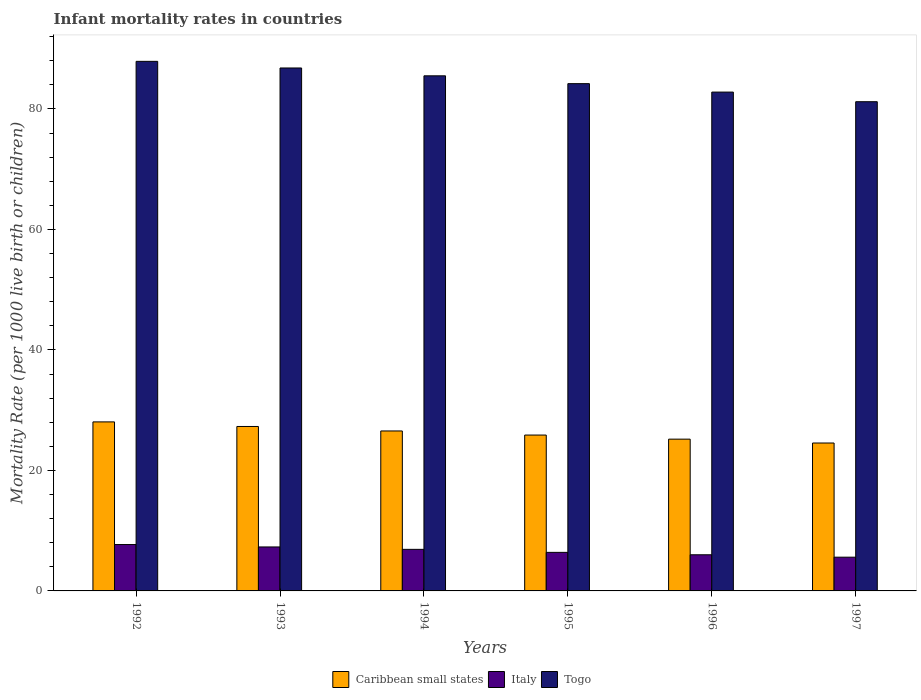How many different coloured bars are there?
Your answer should be compact. 3. Are the number of bars per tick equal to the number of legend labels?
Your response must be concise. Yes. How many bars are there on the 1st tick from the left?
Give a very brief answer. 3. How many bars are there on the 5th tick from the right?
Give a very brief answer. 3. What is the label of the 6th group of bars from the left?
Provide a short and direct response. 1997. What is the infant mortality rate in Caribbean small states in 1995?
Your answer should be compact. 25.87. Across all years, what is the maximum infant mortality rate in Togo?
Provide a succinct answer. 87.9. Across all years, what is the minimum infant mortality rate in Caribbean small states?
Provide a short and direct response. 24.55. What is the total infant mortality rate in Caribbean small states in the graph?
Your answer should be very brief. 157.52. What is the difference between the infant mortality rate in Italy in 1993 and that in 1995?
Ensure brevity in your answer.  0.9. What is the difference between the infant mortality rate in Caribbean small states in 1992 and the infant mortality rate in Togo in 1996?
Offer a very short reply. -54.74. What is the average infant mortality rate in Caribbean small states per year?
Provide a short and direct response. 26.25. In the year 1993, what is the difference between the infant mortality rate in Caribbean small states and infant mortality rate in Italy?
Your answer should be compact. 20. What is the ratio of the infant mortality rate in Caribbean small states in 1992 to that in 1995?
Provide a succinct answer. 1.08. Is the difference between the infant mortality rate in Caribbean small states in 1993 and 1994 greater than the difference between the infant mortality rate in Italy in 1993 and 1994?
Give a very brief answer. Yes. What is the difference between the highest and the second highest infant mortality rate in Italy?
Your response must be concise. 0.4. What is the difference between the highest and the lowest infant mortality rate in Caribbean small states?
Your answer should be very brief. 3.5. In how many years, is the infant mortality rate in Togo greater than the average infant mortality rate in Togo taken over all years?
Provide a short and direct response. 3. What does the 1st bar from the left in 1996 represents?
Offer a terse response. Caribbean small states. What does the 2nd bar from the right in 1994 represents?
Your answer should be very brief. Italy. Is it the case that in every year, the sum of the infant mortality rate in Togo and infant mortality rate in Italy is greater than the infant mortality rate in Caribbean small states?
Provide a succinct answer. Yes. How many years are there in the graph?
Offer a very short reply. 6. What is the difference between two consecutive major ticks on the Y-axis?
Your response must be concise. 20. Are the values on the major ticks of Y-axis written in scientific E-notation?
Offer a very short reply. No. Does the graph contain grids?
Ensure brevity in your answer.  No. How many legend labels are there?
Your answer should be compact. 3. How are the legend labels stacked?
Provide a short and direct response. Horizontal. What is the title of the graph?
Offer a terse response. Infant mortality rates in countries. What is the label or title of the Y-axis?
Keep it short and to the point. Mortality Rate (per 1000 live birth or children). What is the Mortality Rate (per 1000 live birth or children) in Caribbean small states in 1992?
Provide a succinct answer. 28.06. What is the Mortality Rate (per 1000 live birth or children) in Italy in 1992?
Your answer should be compact. 7.7. What is the Mortality Rate (per 1000 live birth or children) in Togo in 1992?
Offer a terse response. 87.9. What is the Mortality Rate (per 1000 live birth or children) of Caribbean small states in 1993?
Ensure brevity in your answer.  27.3. What is the Mortality Rate (per 1000 live birth or children) of Italy in 1993?
Offer a terse response. 7.3. What is the Mortality Rate (per 1000 live birth or children) of Togo in 1993?
Your response must be concise. 86.8. What is the Mortality Rate (per 1000 live birth or children) of Caribbean small states in 1994?
Your answer should be compact. 26.55. What is the Mortality Rate (per 1000 live birth or children) in Togo in 1994?
Offer a terse response. 85.5. What is the Mortality Rate (per 1000 live birth or children) in Caribbean small states in 1995?
Your response must be concise. 25.87. What is the Mortality Rate (per 1000 live birth or children) of Togo in 1995?
Ensure brevity in your answer.  84.2. What is the Mortality Rate (per 1000 live birth or children) in Caribbean small states in 1996?
Your answer should be very brief. 25.19. What is the Mortality Rate (per 1000 live birth or children) of Italy in 1996?
Keep it short and to the point. 6. What is the Mortality Rate (per 1000 live birth or children) of Togo in 1996?
Offer a terse response. 82.8. What is the Mortality Rate (per 1000 live birth or children) of Caribbean small states in 1997?
Keep it short and to the point. 24.55. What is the Mortality Rate (per 1000 live birth or children) in Italy in 1997?
Your response must be concise. 5.6. What is the Mortality Rate (per 1000 live birth or children) of Togo in 1997?
Make the answer very short. 81.2. Across all years, what is the maximum Mortality Rate (per 1000 live birth or children) of Caribbean small states?
Offer a very short reply. 28.06. Across all years, what is the maximum Mortality Rate (per 1000 live birth or children) in Togo?
Your response must be concise. 87.9. Across all years, what is the minimum Mortality Rate (per 1000 live birth or children) in Caribbean small states?
Provide a short and direct response. 24.55. Across all years, what is the minimum Mortality Rate (per 1000 live birth or children) in Italy?
Make the answer very short. 5.6. Across all years, what is the minimum Mortality Rate (per 1000 live birth or children) in Togo?
Give a very brief answer. 81.2. What is the total Mortality Rate (per 1000 live birth or children) in Caribbean small states in the graph?
Ensure brevity in your answer.  157.52. What is the total Mortality Rate (per 1000 live birth or children) in Italy in the graph?
Your response must be concise. 39.9. What is the total Mortality Rate (per 1000 live birth or children) of Togo in the graph?
Ensure brevity in your answer.  508.4. What is the difference between the Mortality Rate (per 1000 live birth or children) in Caribbean small states in 1992 and that in 1993?
Ensure brevity in your answer.  0.76. What is the difference between the Mortality Rate (per 1000 live birth or children) of Caribbean small states in 1992 and that in 1994?
Provide a short and direct response. 1.5. What is the difference between the Mortality Rate (per 1000 live birth or children) of Caribbean small states in 1992 and that in 1995?
Your answer should be very brief. 2.18. What is the difference between the Mortality Rate (per 1000 live birth or children) in Caribbean small states in 1992 and that in 1996?
Your response must be concise. 2.86. What is the difference between the Mortality Rate (per 1000 live birth or children) in Italy in 1992 and that in 1996?
Ensure brevity in your answer.  1.7. What is the difference between the Mortality Rate (per 1000 live birth or children) of Togo in 1992 and that in 1996?
Offer a very short reply. 5.1. What is the difference between the Mortality Rate (per 1000 live birth or children) in Caribbean small states in 1992 and that in 1997?
Give a very brief answer. 3.5. What is the difference between the Mortality Rate (per 1000 live birth or children) in Togo in 1992 and that in 1997?
Provide a succinct answer. 6.7. What is the difference between the Mortality Rate (per 1000 live birth or children) of Caribbean small states in 1993 and that in 1994?
Offer a very short reply. 0.74. What is the difference between the Mortality Rate (per 1000 live birth or children) of Italy in 1993 and that in 1994?
Ensure brevity in your answer.  0.4. What is the difference between the Mortality Rate (per 1000 live birth or children) of Togo in 1993 and that in 1994?
Give a very brief answer. 1.3. What is the difference between the Mortality Rate (per 1000 live birth or children) of Caribbean small states in 1993 and that in 1995?
Give a very brief answer. 1.42. What is the difference between the Mortality Rate (per 1000 live birth or children) in Caribbean small states in 1993 and that in 1996?
Ensure brevity in your answer.  2.1. What is the difference between the Mortality Rate (per 1000 live birth or children) of Togo in 1993 and that in 1996?
Ensure brevity in your answer.  4. What is the difference between the Mortality Rate (per 1000 live birth or children) of Caribbean small states in 1993 and that in 1997?
Your answer should be very brief. 2.74. What is the difference between the Mortality Rate (per 1000 live birth or children) of Italy in 1993 and that in 1997?
Offer a very short reply. 1.7. What is the difference between the Mortality Rate (per 1000 live birth or children) of Togo in 1993 and that in 1997?
Make the answer very short. 5.6. What is the difference between the Mortality Rate (per 1000 live birth or children) of Caribbean small states in 1994 and that in 1995?
Offer a terse response. 0.68. What is the difference between the Mortality Rate (per 1000 live birth or children) in Italy in 1994 and that in 1995?
Provide a short and direct response. 0.5. What is the difference between the Mortality Rate (per 1000 live birth or children) in Togo in 1994 and that in 1995?
Your response must be concise. 1.3. What is the difference between the Mortality Rate (per 1000 live birth or children) in Caribbean small states in 1994 and that in 1996?
Give a very brief answer. 1.36. What is the difference between the Mortality Rate (per 1000 live birth or children) of Togo in 1994 and that in 1996?
Keep it short and to the point. 2.7. What is the difference between the Mortality Rate (per 1000 live birth or children) of Caribbean small states in 1994 and that in 1997?
Offer a very short reply. 2. What is the difference between the Mortality Rate (per 1000 live birth or children) in Togo in 1994 and that in 1997?
Offer a terse response. 4.3. What is the difference between the Mortality Rate (per 1000 live birth or children) of Caribbean small states in 1995 and that in 1996?
Provide a succinct answer. 0.68. What is the difference between the Mortality Rate (per 1000 live birth or children) in Italy in 1995 and that in 1996?
Your answer should be compact. 0.4. What is the difference between the Mortality Rate (per 1000 live birth or children) of Caribbean small states in 1995 and that in 1997?
Give a very brief answer. 1.32. What is the difference between the Mortality Rate (per 1000 live birth or children) of Caribbean small states in 1996 and that in 1997?
Provide a short and direct response. 0.64. What is the difference between the Mortality Rate (per 1000 live birth or children) in Italy in 1996 and that in 1997?
Make the answer very short. 0.4. What is the difference between the Mortality Rate (per 1000 live birth or children) of Caribbean small states in 1992 and the Mortality Rate (per 1000 live birth or children) of Italy in 1993?
Your response must be concise. 20.76. What is the difference between the Mortality Rate (per 1000 live birth or children) of Caribbean small states in 1992 and the Mortality Rate (per 1000 live birth or children) of Togo in 1993?
Ensure brevity in your answer.  -58.74. What is the difference between the Mortality Rate (per 1000 live birth or children) in Italy in 1992 and the Mortality Rate (per 1000 live birth or children) in Togo in 1993?
Your answer should be compact. -79.1. What is the difference between the Mortality Rate (per 1000 live birth or children) in Caribbean small states in 1992 and the Mortality Rate (per 1000 live birth or children) in Italy in 1994?
Offer a very short reply. 21.16. What is the difference between the Mortality Rate (per 1000 live birth or children) in Caribbean small states in 1992 and the Mortality Rate (per 1000 live birth or children) in Togo in 1994?
Make the answer very short. -57.44. What is the difference between the Mortality Rate (per 1000 live birth or children) of Italy in 1992 and the Mortality Rate (per 1000 live birth or children) of Togo in 1994?
Keep it short and to the point. -77.8. What is the difference between the Mortality Rate (per 1000 live birth or children) in Caribbean small states in 1992 and the Mortality Rate (per 1000 live birth or children) in Italy in 1995?
Provide a short and direct response. 21.66. What is the difference between the Mortality Rate (per 1000 live birth or children) in Caribbean small states in 1992 and the Mortality Rate (per 1000 live birth or children) in Togo in 1995?
Your response must be concise. -56.14. What is the difference between the Mortality Rate (per 1000 live birth or children) in Italy in 1992 and the Mortality Rate (per 1000 live birth or children) in Togo in 1995?
Give a very brief answer. -76.5. What is the difference between the Mortality Rate (per 1000 live birth or children) of Caribbean small states in 1992 and the Mortality Rate (per 1000 live birth or children) of Italy in 1996?
Make the answer very short. 22.06. What is the difference between the Mortality Rate (per 1000 live birth or children) of Caribbean small states in 1992 and the Mortality Rate (per 1000 live birth or children) of Togo in 1996?
Provide a short and direct response. -54.74. What is the difference between the Mortality Rate (per 1000 live birth or children) in Italy in 1992 and the Mortality Rate (per 1000 live birth or children) in Togo in 1996?
Offer a terse response. -75.1. What is the difference between the Mortality Rate (per 1000 live birth or children) in Caribbean small states in 1992 and the Mortality Rate (per 1000 live birth or children) in Italy in 1997?
Offer a terse response. 22.46. What is the difference between the Mortality Rate (per 1000 live birth or children) in Caribbean small states in 1992 and the Mortality Rate (per 1000 live birth or children) in Togo in 1997?
Your answer should be compact. -53.14. What is the difference between the Mortality Rate (per 1000 live birth or children) in Italy in 1992 and the Mortality Rate (per 1000 live birth or children) in Togo in 1997?
Your answer should be very brief. -73.5. What is the difference between the Mortality Rate (per 1000 live birth or children) of Caribbean small states in 1993 and the Mortality Rate (per 1000 live birth or children) of Italy in 1994?
Make the answer very short. 20.4. What is the difference between the Mortality Rate (per 1000 live birth or children) in Caribbean small states in 1993 and the Mortality Rate (per 1000 live birth or children) in Togo in 1994?
Your answer should be compact. -58.2. What is the difference between the Mortality Rate (per 1000 live birth or children) in Italy in 1993 and the Mortality Rate (per 1000 live birth or children) in Togo in 1994?
Give a very brief answer. -78.2. What is the difference between the Mortality Rate (per 1000 live birth or children) of Caribbean small states in 1993 and the Mortality Rate (per 1000 live birth or children) of Italy in 1995?
Your answer should be very brief. 20.9. What is the difference between the Mortality Rate (per 1000 live birth or children) of Caribbean small states in 1993 and the Mortality Rate (per 1000 live birth or children) of Togo in 1995?
Provide a short and direct response. -56.9. What is the difference between the Mortality Rate (per 1000 live birth or children) of Italy in 1993 and the Mortality Rate (per 1000 live birth or children) of Togo in 1995?
Give a very brief answer. -76.9. What is the difference between the Mortality Rate (per 1000 live birth or children) of Caribbean small states in 1993 and the Mortality Rate (per 1000 live birth or children) of Italy in 1996?
Your answer should be very brief. 21.3. What is the difference between the Mortality Rate (per 1000 live birth or children) of Caribbean small states in 1993 and the Mortality Rate (per 1000 live birth or children) of Togo in 1996?
Make the answer very short. -55.5. What is the difference between the Mortality Rate (per 1000 live birth or children) of Italy in 1993 and the Mortality Rate (per 1000 live birth or children) of Togo in 1996?
Keep it short and to the point. -75.5. What is the difference between the Mortality Rate (per 1000 live birth or children) in Caribbean small states in 1993 and the Mortality Rate (per 1000 live birth or children) in Italy in 1997?
Provide a short and direct response. 21.7. What is the difference between the Mortality Rate (per 1000 live birth or children) in Caribbean small states in 1993 and the Mortality Rate (per 1000 live birth or children) in Togo in 1997?
Offer a terse response. -53.9. What is the difference between the Mortality Rate (per 1000 live birth or children) in Italy in 1993 and the Mortality Rate (per 1000 live birth or children) in Togo in 1997?
Your response must be concise. -73.9. What is the difference between the Mortality Rate (per 1000 live birth or children) of Caribbean small states in 1994 and the Mortality Rate (per 1000 live birth or children) of Italy in 1995?
Give a very brief answer. 20.15. What is the difference between the Mortality Rate (per 1000 live birth or children) of Caribbean small states in 1994 and the Mortality Rate (per 1000 live birth or children) of Togo in 1995?
Make the answer very short. -57.65. What is the difference between the Mortality Rate (per 1000 live birth or children) of Italy in 1994 and the Mortality Rate (per 1000 live birth or children) of Togo in 1995?
Give a very brief answer. -77.3. What is the difference between the Mortality Rate (per 1000 live birth or children) in Caribbean small states in 1994 and the Mortality Rate (per 1000 live birth or children) in Italy in 1996?
Give a very brief answer. 20.55. What is the difference between the Mortality Rate (per 1000 live birth or children) in Caribbean small states in 1994 and the Mortality Rate (per 1000 live birth or children) in Togo in 1996?
Your response must be concise. -56.25. What is the difference between the Mortality Rate (per 1000 live birth or children) in Italy in 1994 and the Mortality Rate (per 1000 live birth or children) in Togo in 1996?
Your answer should be compact. -75.9. What is the difference between the Mortality Rate (per 1000 live birth or children) of Caribbean small states in 1994 and the Mortality Rate (per 1000 live birth or children) of Italy in 1997?
Give a very brief answer. 20.95. What is the difference between the Mortality Rate (per 1000 live birth or children) of Caribbean small states in 1994 and the Mortality Rate (per 1000 live birth or children) of Togo in 1997?
Provide a short and direct response. -54.65. What is the difference between the Mortality Rate (per 1000 live birth or children) of Italy in 1994 and the Mortality Rate (per 1000 live birth or children) of Togo in 1997?
Your answer should be very brief. -74.3. What is the difference between the Mortality Rate (per 1000 live birth or children) in Caribbean small states in 1995 and the Mortality Rate (per 1000 live birth or children) in Italy in 1996?
Your response must be concise. 19.87. What is the difference between the Mortality Rate (per 1000 live birth or children) of Caribbean small states in 1995 and the Mortality Rate (per 1000 live birth or children) of Togo in 1996?
Ensure brevity in your answer.  -56.93. What is the difference between the Mortality Rate (per 1000 live birth or children) in Italy in 1995 and the Mortality Rate (per 1000 live birth or children) in Togo in 1996?
Your answer should be very brief. -76.4. What is the difference between the Mortality Rate (per 1000 live birth or children) of Caribbean small states in 1995 and the Mortality Rate (per 1000 live birth or children) of Italy in 1997?
Keep it short and to the point. 20.27. What is the difference between the Mortality Rate (per 1000 live birth or children) in Caribbean small states in 1995 and the Mortality Rate (per 1000 live birth or children) in Togo in 1997?
Give a very brief answer. -55.33. What is the difference between the Mortality Rate (per 1000 live birth or children) in Italy in 1995 and the Mortality Rate (per 1000 live birth or children) in Togo in 1997?
Your answer should be very brief. -74.8. What is the difference between the Mortality Rate (per 1000 live birth or children) in Caribbean small states in 1996 and the Mortality Rate (per 1000 live birth or children) in Italy in 1997?
Your response must be concise. 19.59. What is the difference between the Mortality Rate (per 1000 live birth or children) of Caribbean small states in 1996 and the Mortality Rate (per 1000 live birth or children) of Togo in 1997?
Your response must be concise. -56.01. What is the difference between the Mortality Rate (per 1000 live birth or children) of Italy in 1996 and the Mortality Rate (per 1000 live birth or children) of Togo in 1997?
Give a very brief answer. -75.2. What is the average Mortality Rate (per 1000 live birth or children) in Caribbean small states per year?
Offer a terse response. 26.25. What is the average Mortality Rate (per 1000 live birth or children) in Italy per year?
Provide a short and direct response. 6.65. What is the average Mortality Rate (per 1000 live birth or children) in Togo per year?
Keep it short and to the point. 84.73. In the year 1992, what is the difference between the Mortality Rate (per 1000 live birth or children) of Caribbean small states and Mortality Rate (per 1000 live birth or children) of Italy?
Provide a succinct answer. 20.36. In the year 1992, what is the difference between the Mortality Rate (per 1000 live birth or children) in Caribbean small states and Mortality Rate (per 1000 live birth or children) in Togo?
Your response must be concise. -59.84. In the year 1992, what is the difference between the Mortality Rate (per 1000 live birth or children) of Italy and Mortality Rate (per 1000 live birth or children) of Togo?
Your answer should be very brief. -80.2. In the year 1993, what is the difference between the Mortality Rate (per 1000 live birth or children) in Caribbean small states and Mortality Rate (per 1000 live birth or children) in Italy?
Provide a succinct answer. 20. In the year 1993, what is the difference between the Mortality Rate (per 1000 live birth or children) of Caribbean small states and Mortality Rate (per 1000 live birth or children) of Togo?
Your answer should be very brief. -59.5. In the year 1993, what is the difference between the Mortality Rate (per 1000 live birth or children) in Italy and Mortality Rate (per 1000 live birth or children) in Togo?
Ensure brevity in your answer.  -79.5. In the year 1994, what is the difference between the Mortality Rate (per 1000 live birth or children) in Caribbean small states and Mortality Rate (per 1000 live birth or children) in Italy?
Make the answer very short. 19.65. In the year 1994, what is the difference between the Mortality Rate (per 1000 live birth or children) of Caribbean small states and Mortality Rate (per 1000 live birth or children) of Togo?
Provide a short and direct response. -58.95. In the year 1994, what is the difference between the Mortality Rate (per 1000 live birth or children) of Italy and Mortality Rate (per 1000 live birth or children) of Togo?
Offer a terse response. -78.6. In the year 1995, what is the difference between the Mortality Rate (per 1000 live birth or children) in Caribbean small states and Mortality Rate (per 1000 live birth or children) in Italy?
Offer a terse response. 19.47. In the year 1995, what is the difference between the Mortality Rate (per 1000 live birth or children) in Caribbean small states and Mortality Rate (per 1000 live birth or children) in Togo?
Your response must be concise. -58.33. In the year 1995, what is the difference between the Mortality Rate (per 1000 live birth or children) of Italy and Mortality Rate (per 1000 live birth or children) of Togo?
Your answer should be compact. -77.8. In the year 1996, what is the difference between the Mortality Rate (per 1000 live birth or children) of Caribbean small states and Mortality Rate (per 1000 live birth or children) of Italy?
Make the answer very short. 19.19. In the year 1996, what is the difference between the Mortality Rate (per 1000 live birth or children) in Caribbean small states and Mortality Rate (per 1000 live birth or children) in Togo?
Keep it short and to the point. -57.61. In the year 1996, what is the difference between the Mortality Rate (per 1000 live birth or children) of Italy and Mortality Rate (per 1000 live birth or children) of Togo?
Provide a short and direct response. -76.8. In the year 1997, what is the difference between the Mortality Rate (per 1000 live birth or children) of Caribbean small states and Mortality Rate (per 1000 live birth or children) of Italy?
Provide a short and direct response. 18.95. In the year 1997, what is the difference between the Mortality Rate (per 1000 live birth or children) in Caribbean small states and Mortality Rate (per 1000 live birth or children) in Togo?
Keep it short and to the point. -56.65. In the year 1997, what is the difference between the Mortality Rate (per 1000 live birth or children) of Italy and Mortality Rate (per 1000 live birth or children) of Togo?
Provide a short and direct response. -75.6. What is the ratio of the Mortality Rate (per 1000 live birth or children) of Caribbean small states in 1992 to that in 1993?
Offer a very short reply. 1.03. What is the ratio of the Mortality Rate (per 1000 live birth or children) in Italy in 1992 to that in 1993?
Your answer should be compact. 1.05. What is the ratio of the Mortality Rate (per 1000 live birth or children) in Togo in 1992 to that in 1993?
Offer a terse response. 1.01. What is the ratio of the Mortality Rate (per 1000 live birth or children) in Caribbean small states in 1992 to that in 1994?
Provide a short and direct response. 1.06. What is the ratio of the Mortality Rate (per 1000 live birth or children) of Italy in 1992 to that in 1994?
Your answer should be compact. 1.12. What is the ratio of the Mortality Rate (per 1000 live birth or children) in Togo in 1992 to that in 1994?
Keep it short and to the point. 1.03. What is the ratio of the Mortality Rate (per 1000 live birth or children) of Caribbean small states in 1992 to that in 1995?
Your response must be concise. 1.08. What is the ratio of the Mortality Rate (per 1000 live birth or children) in Italy in 1992 to that in 1995?
Your answer should be compact. 1.2. What is the ratio of the Mortality Rate (per 1000 live birth or children) of Togo in 1992 to that in 1995?
Make the answer very short. 1.04. What is the ratio of the Mortality Rate (per 1000 live birth or children) of Caribbean small states in 1992 to that in 1996?
Your answer should be very brief. 1.11. What is the ratio of the Mortality Rate (per 1000 live birth or children) of Italy in 1992 to that in 1996?
Offer a terse response. 1.28. What is the ratio of the Mortality Rate (per 1000 live birth or children) of Togo in 1992 to that in 1996?
Your response must be concise. 1.06. What is the ratio of the Mortality Rate (per 1000 live birth or children) in Caribbean small states in 1992 to that in 1997?
Ensure brevity in your answer.  1.14. What is the ratio of the Mortality Rate (per 1000 live birth or children) of Italy in 1992 to that in 1997?
Keep it short and to the point. 1.38. What is the ratio of the Mortality Rate (per 1000 live birth or children) of Togo in 1992 to that in 1997?
Offer a very short reply. 1.08. What is the ratio of the Mortality Rate (per 1000 live birth or children) in Caribbean small states in 1993 to that in 1994?
Offer a terse response. 1.03. What is the ratio of the Mortality Rate (per 1000 live birth or children) in Italy in 1993 to that in 1994?
Make the answer very short. 1.06. What is the ratio of the Mortality Rate (per 1000 live birth or children) in Togo in 1993 to that in 1994?
Your answer should be very brief. 1.02. What is the ratio of the Mortality Rate (per 1000 live birth or children) in Caribbean small states in 1993 to that in 1995?
Ensure brevity in your answer.  1.05. What is the ratio of the Mortality Rate (per 1000 live birth or children) of Italy in 1993 to that in 1995?
Ensure brevity in your answer.  1.14. What is the ratio of the Mortality Rate (per 1000 live birth or children) of Togo in 1993 to that in 1995?
Provide a short and direct response. 1.03. What is the ratio of the Mortality Rate (per 1000 live birth or children) in Caribbean small states in 1993 to that in 1996?
Offer a very short reply. 1.08. What is the ratio of the Mortality Rate (per 1000 live birth or children) of Italy in 1993 to that in 1996?
Your answer should be compact. 1.22. What is the ratio of the Mortality Rate (per 1000 live birth or children) of Togo in 1993 to that in 1996?
Give a very brief answer. 1.05. What is the ratio of the Mortality Rate (per 1000 live birth or children) in Caribbean small states in 1993 to that in 1997?
Make the answer very short. 1.11. What is the ratio of the Mortality Rate (per 1000 live birth or children) in Italy in 1993 to that in 1997?
Your response must be concise. 1.3. What is the ratio of the Mortality Rate (per 1000 live birth or children) in Togo in 1993 to that in 1997?
Make the answer very short. 1.07. What is the ratio of the Mortality Rate (per 1000 live birth or children) of Caribbean small states in 1994 to that in 1995?
Offer a very short reply. 1.03. What is the ratio of the Mortality Rate (per 1000 live birth or children) in Italy in 1994 to that in 1995?
Offer a very short reply. 1.08. What is the ratio of the Mortality Rate (per 1000 live birth or children) of Togo in 1994 to that in 1995?
Ensure brevity in your answer.  1.02. What is the ratio of the Mortality Rate (per 1000 live birth or children) of Caribbean small states in 1994 to that in 1996?
Your answer should be compact. 1.05. What is the ratio of the Mortality Rate (per 1000 live birth or children) of Italy in 1994 to that in 1996?
Ensure brevity in your answer.  1.15. What is the ratio of the Mortality Rate (per 1000 live birth or children) of Togo in 1994 to that in 1996?
Your answer should be compact. 1.03. What is the ratio of the Mortality Rate (per 1000 live birth or children) of Caribbean small states in 1994 to that in 1997?
Give a very brief answer. 1.08. What is the ratio of the Mortality Rate (per 1000 live birth or children) in Italy in 1994 to that in 1997?
Provide a short and direct response. 1.23. What is the ratio of the Mortality Rate (per 1000 live birth or children) of Togo in 1994 to that in 1997?
Your answer should be very brief. 1.05. What is the ratio of the Mortality Rate (per 1000 live birth or children) in Italy in 1995 to that in 1996?
Your response must be concise. 1.07. What is the ratio of the Mortality Rate (per 1000 live birth or children) in Togo in 1995 to that in 1996?
Your answer should be very brief. 1.02. What is the ratio of the Mortality Rate (per 1000 live birth or children) in Caribbean small states in 1995 to that in 1997?
Your answer should be very brief. 1.05. What is the ratio of the Mortality Rate (per 1000 live birth or children) of Togo in 1995 to that in 1997?
Your answer should be very brief. 1.04. What is the ratio of the Mortality Rate (per 1000 live birth or children) of Caribbean small states in 1996 to that in 1997?
Offer a very short reply. 1.03. What is the ratio of the Mortality Rate (per 1000 live birth or children) in Italy in 1996 to that in 1997?
Keep it short and to the point. 1.07. What is the ratio of the Mortality Rate (per 1000 live birth or children) of Togo in 1996 to that in 1997?
Your response must be concise. 1.02. What is the difference between the highest and the second highest Mortality Rate (per 1000 live birth or children) of Caribbean small states?
Ensure brevity in your answer.  0.76. What is the difference between the highest and the second highest Mortality Rate (per 1000 live birth or children) of Italy?
Your answer should be very brief. 0.4. What is the difference between the highest and the second highest Mortality Rate (per 1000 live birth or children) in Togo?
Your response must be concise. 1.1. What is the difference between the highest and the lowest Mortality Rate (per 1000 live birth or children) in Caribbean small states?
Offer a very short reply. 3.5. What is the difference between the highest and the lowest Mortality Rate (per 1000 live birth or children) of Togo?
Provide a succinct answer. 6.7. 